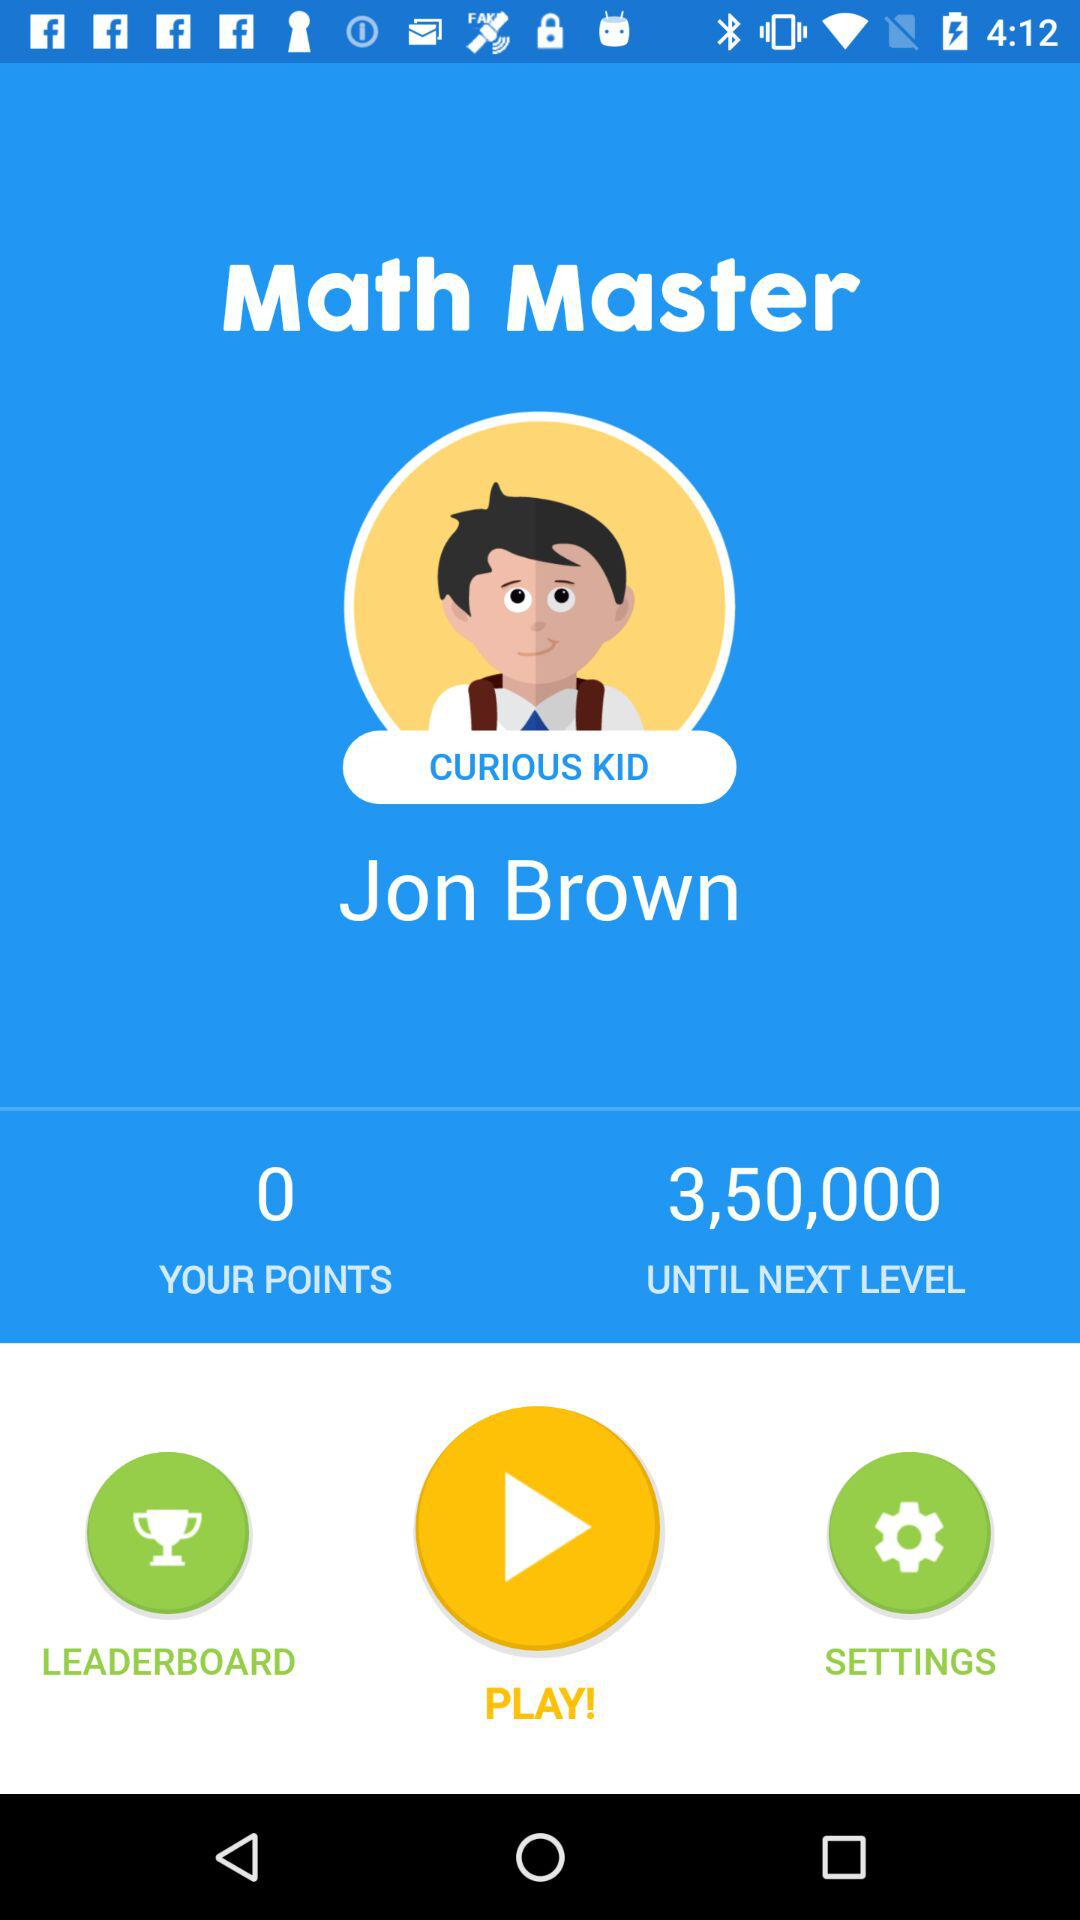How many points are required until the next level? The required number of points is 3,50,000. 